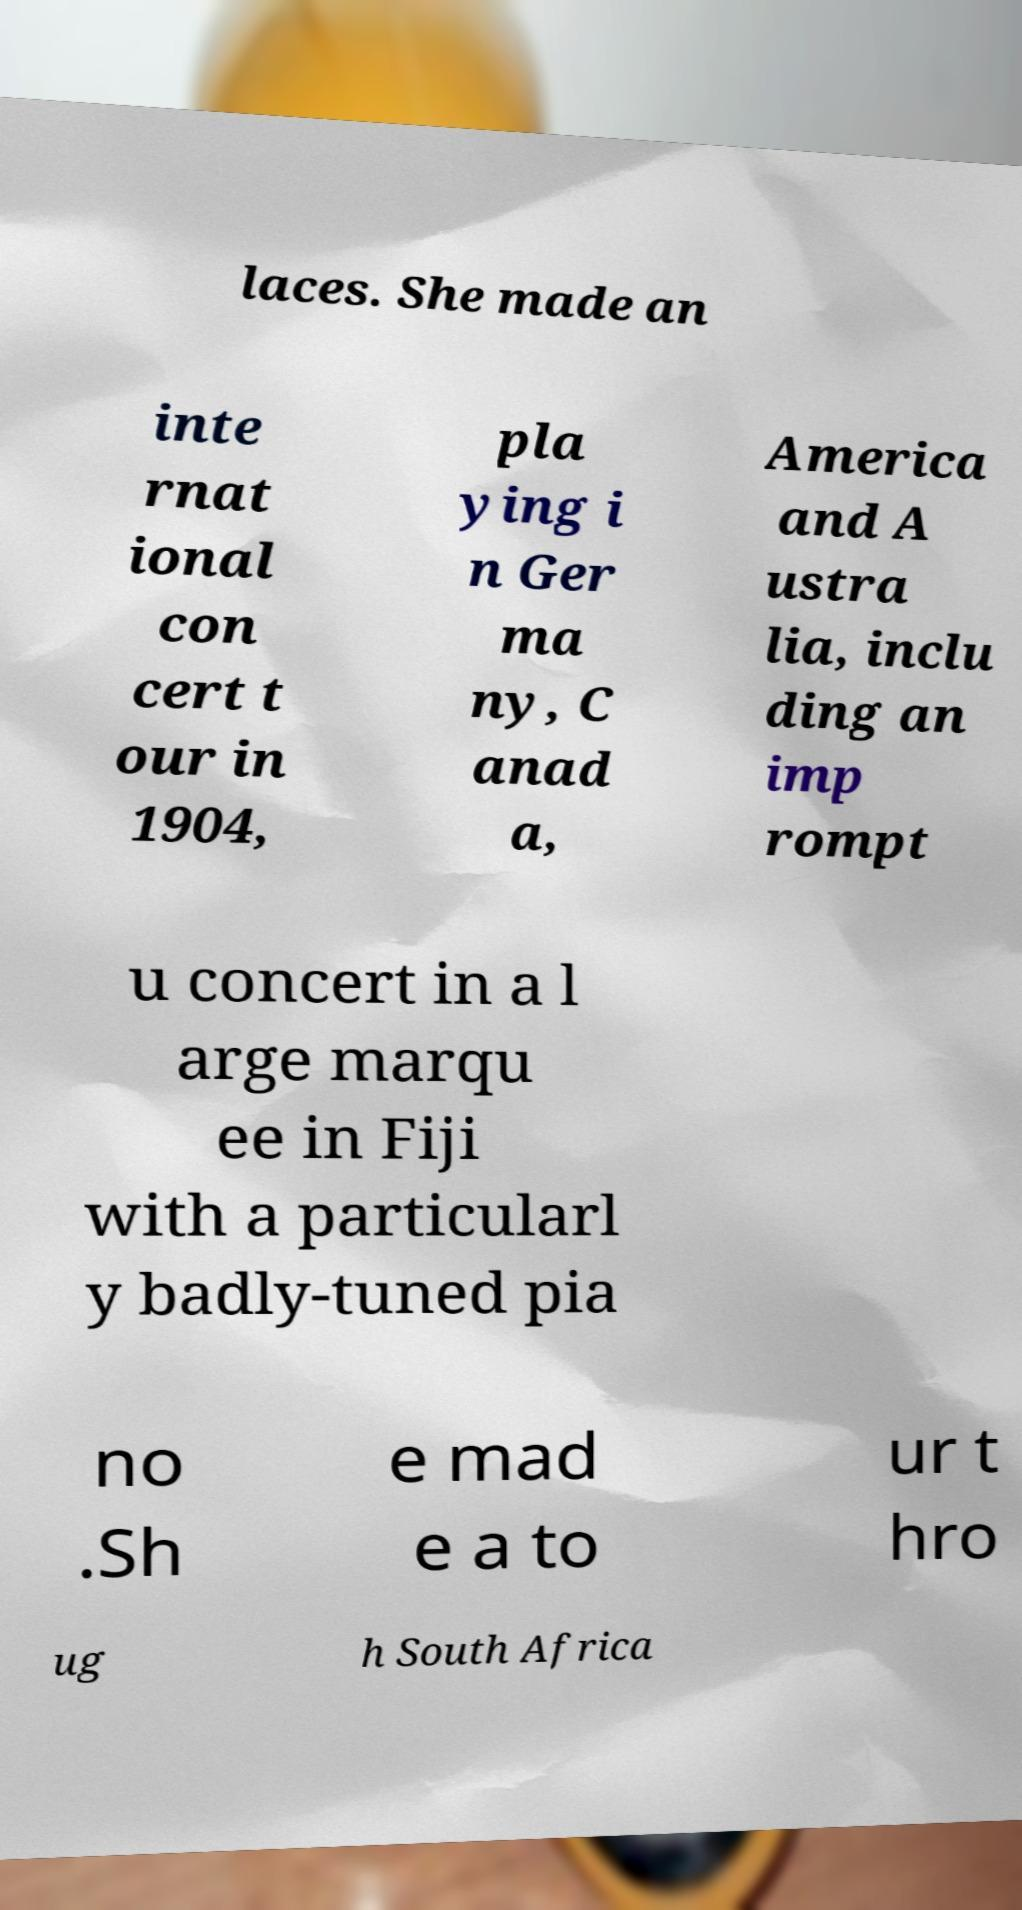Can you read and provide the text displayed in the image?This photo seems to have some interesting text. Can you extract and type it out for me? laces. She made an inte rnat ional con cert t our in 1904, pla ying i n Ger ma ny, C anad a, America and A ustra lia, inclu ding an imp rompt u concert in a l arge marqu ee in Fiji with a particularl y badly-tuned pia no .Sh e mad e a to ur t hro ug h South Africa 